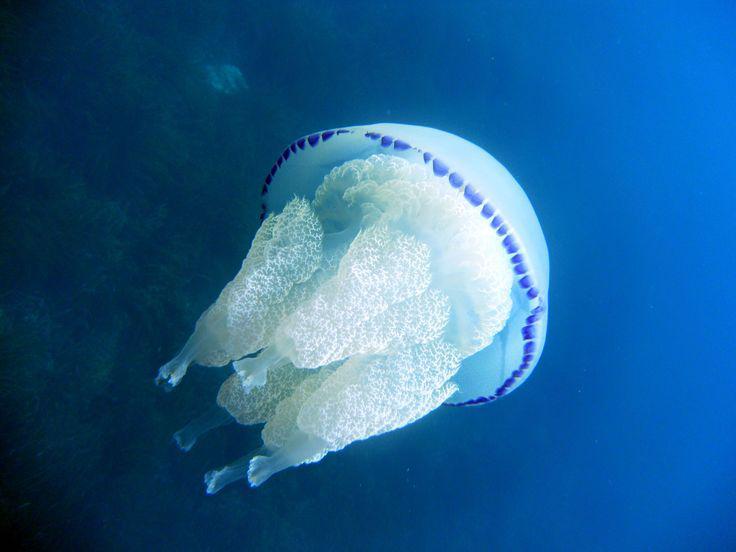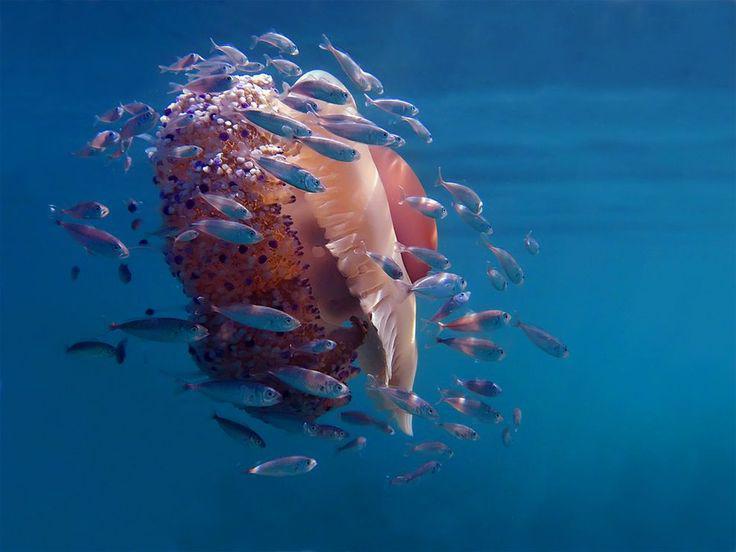The first image is the image on the left, the second image is the image on the right. For the images displayed, is the sentence "The jellyfish in the image on the right is pink." factually correct? Answer yes or no. Yes. 